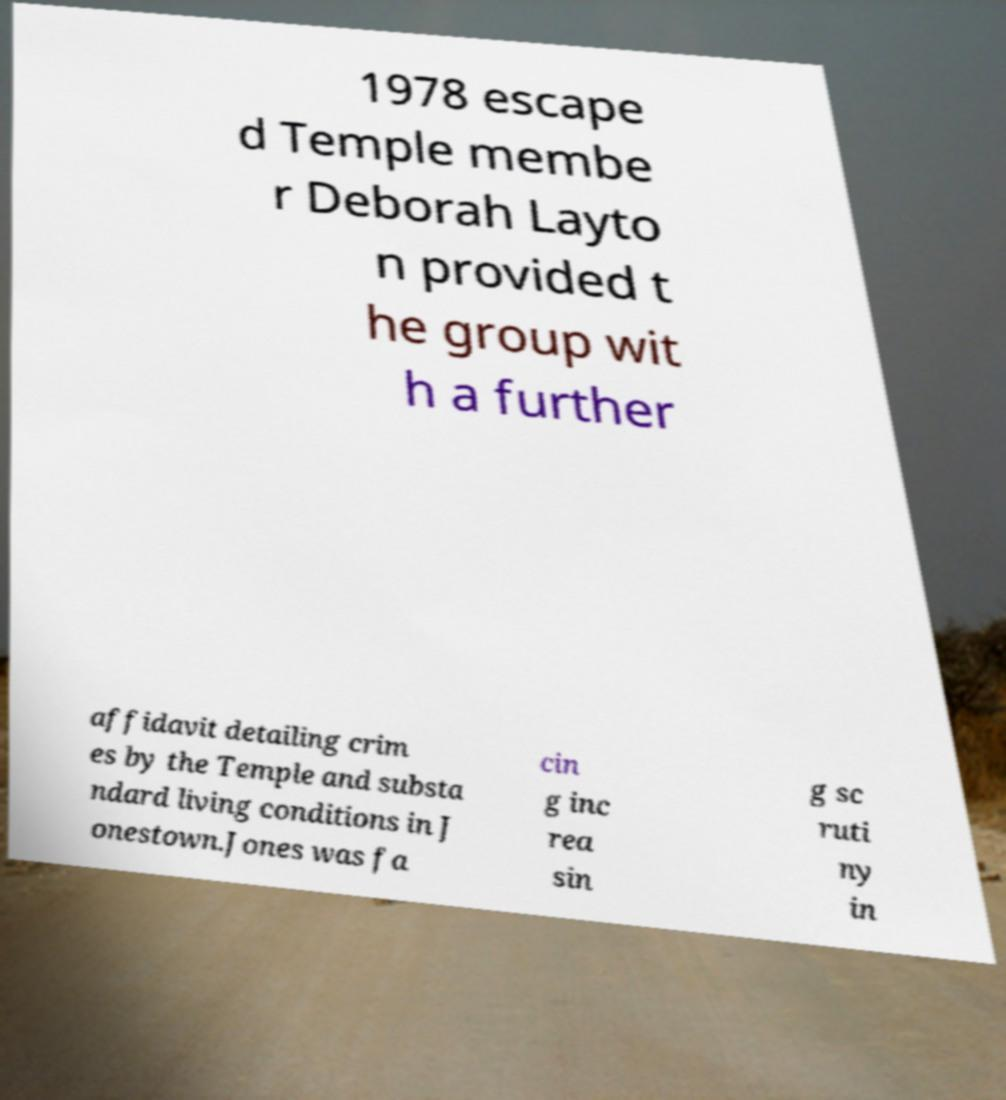For documentation purposes, I need the text within this image transcribed. Could you provide that? 1978 escape d Temple membe r Deborah Layto n provided t he group wit h a further affidavit detailing crim es by the Temple and substa ndard living conditions in J onestown.Jones was fa cin g inc rea sin g sc ruti ny in 